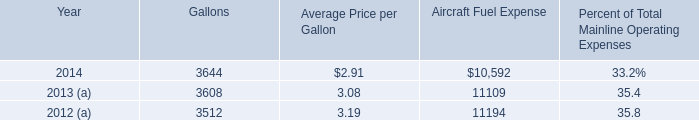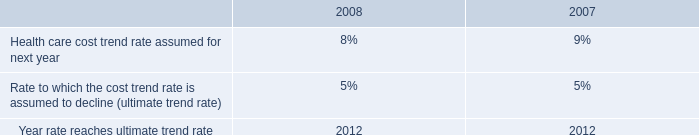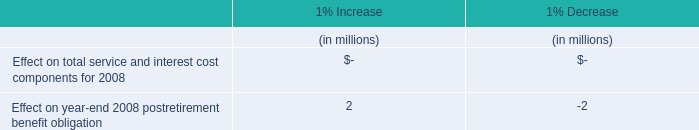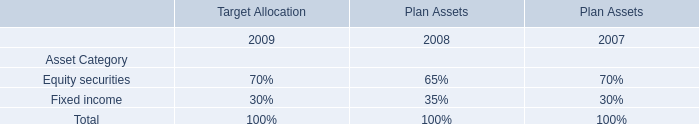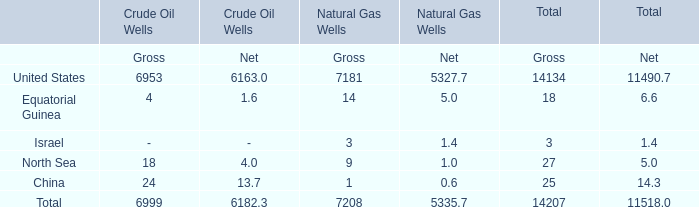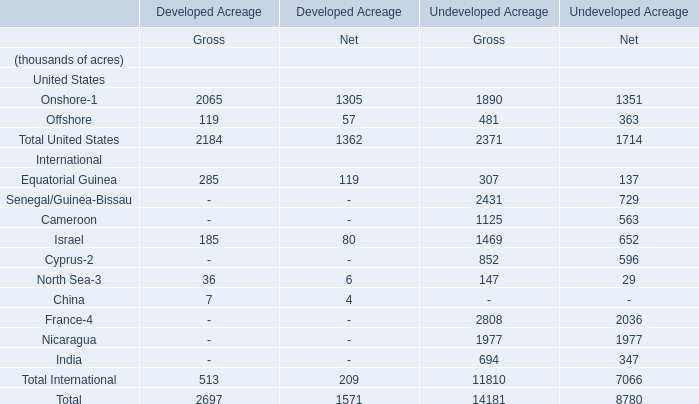In which section is United States greater than 7000？ 
Answer: Natural Gas Wells in Gross. 